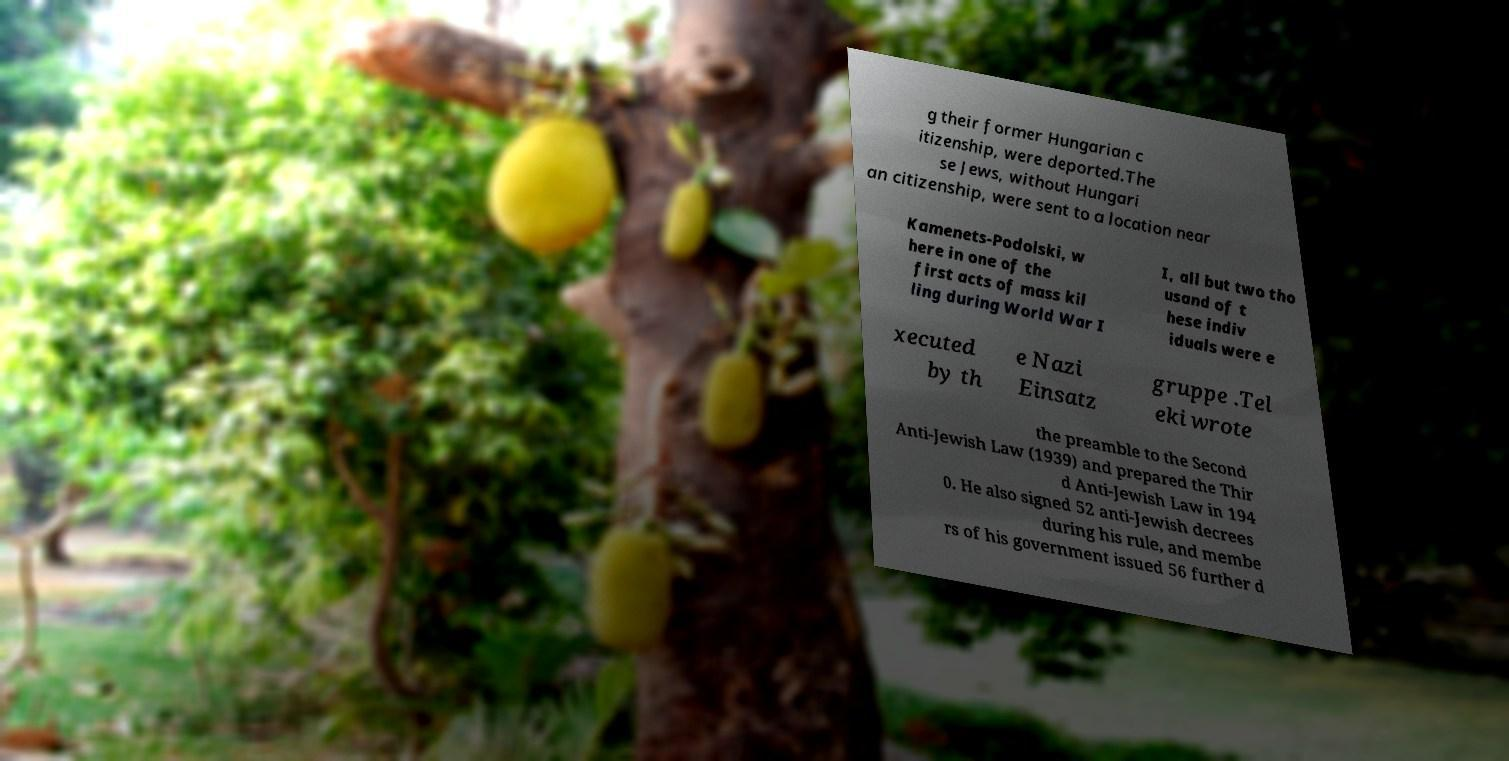Please read and relay the text visible in this image. What does it say? g their former Hungarian c itizenship, were deported.The se Jews, without Hungari an citizenship, were sent to a location near Kamenets-Podolski, w here in one of the first acts of mass kil ling during World War I I, all but two tho usand of t hese indiv iduals were e xecuted by th e Nazi Einsatz gruppe .Tel eki wrote the preamble to the Second Anti-Jewish Law (1939) and prepared the Thir d Anti-Jewish Law in 194 0. He also signed 52 anti-Jewish decrees during his rule, and membe rs of his government issued 56 further d 